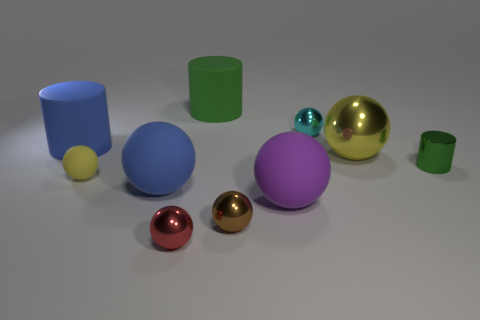How many objects are either cylinders that are left of the brown thing or purple metallic things?
Make the answer very short. 2. How many other things are there of the same color as the small matte ball?
Give a very brief answer. 1. Is the color of the small rubber sphere the same as the large sphere that is behind the tiny green metallic thing?
Offer a terse response. Yes. What is the color of the large metallic thing that is the same shape as the tiny yellow thing?
Provide a succinct answer. Yellow. Does the big green cylinder have the same material as the yellow ball on the left side of the big yellow ball?
Keep it short and to the point. Yes. The tiny matte object has what color?
Provide a succinct answer. Yellow. What is the color of the cylinder that is in front of the large cylinder to the left of the green cylinder that is on the left side of the tiny cyan object?
Make the answer very short. Green. Do the red metal object and the yellow object that is to the right of the cyan shiny thing have the same shape?
Offer a terse response. Yes. The rubber object that is in front of the blue cylinder and to the right of the small red metal object is what color?
Your answer should be compact. Purple. Are there any other cyan metal things that have the same shape as the small cyan shiny thing?
Make the answer very short. No. 